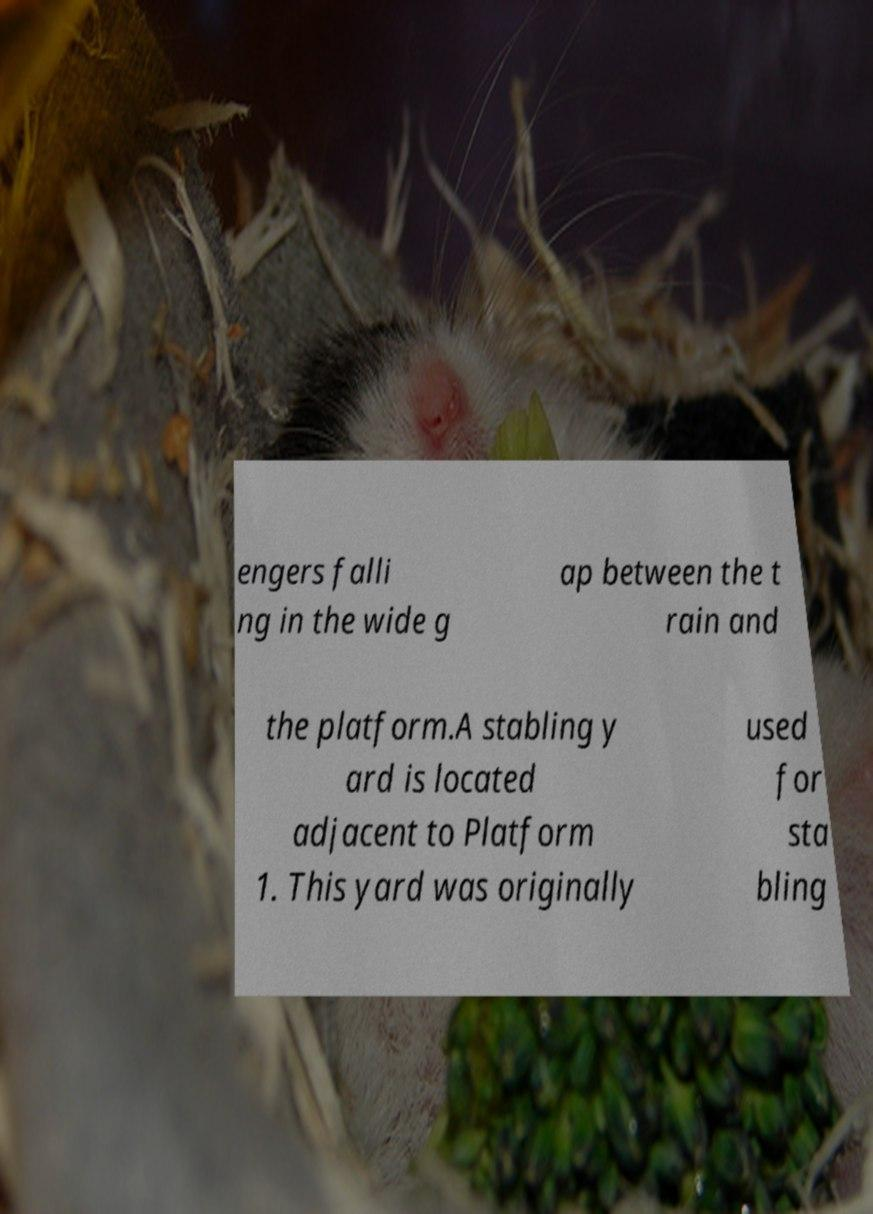Please read and relay the text visible in this image. What does it say? engers falli ng in the wide g ap between the t rain and the platform.A stabling y ard is located adjacent to Platform 1. This yard was originally used for sta bling 